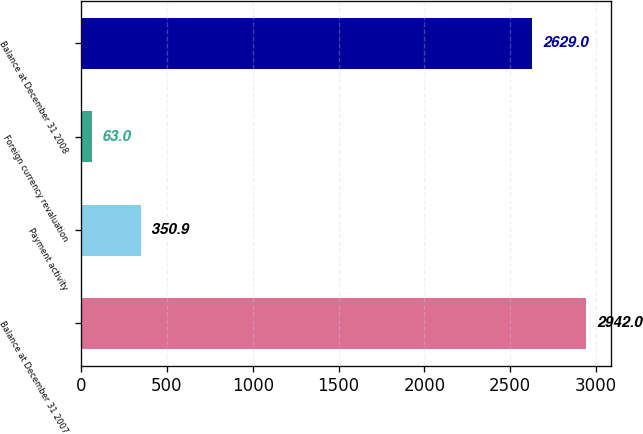Convert chart to OTSL. <chart><loc_0><loc_0><loc_500><loc_500><bar_chart><fcel>Balance at December 31 2007<fcel>Payment activity<fcel>Foreign currency revaluation<fcel>Balance at December 31 2008<nl><fcel>2942<fcel>350.9<fcel>63<fcel>2629<nl></chart> 